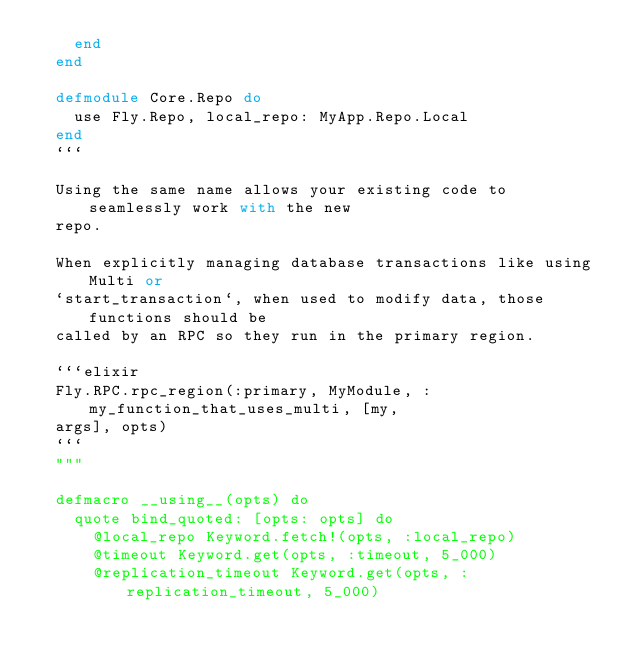<code> <loc_0><loc_0><loc_500><loc_500><_Elixir_>    end
  end

  defmodule Core.Repo do
    use Fly.Repo, local_repo: MyApp.Repo.Local
  end
  ```

  Using the same name allows your existing code to seamlessly work with the new
  repo.

  When explicitly managing database transactions like using Multi or
  `start_transaction`, when used to modify data, those functions should be
  called by an RPC so they run in the primary region.

  ```elixir
  Fly.RPC.rpc_region(:primary, MyModule, :my_function_that_uses_multi, [my,
  args], opts)
  ```
  """

  defmacro __using__(opts) do
    quote bind_quoted: [opts: opts] do
      @local_repo Keyword.fetch!(opts, :local_repo)
      @timeout Keyword.get(opts, :timeout, 5_000)
      @replication_timeout Keyword.get(opts, :replication_timeout, 5_000)
</code> 